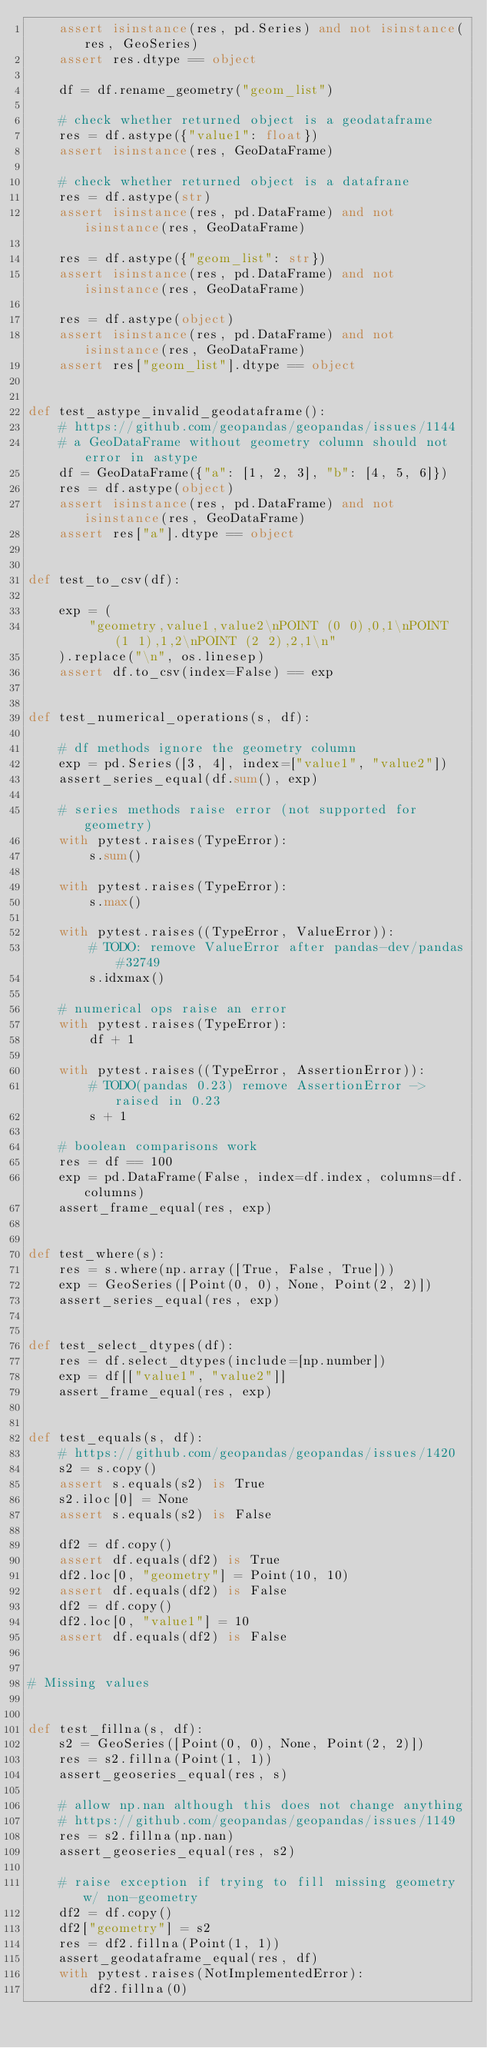<code> <loc_0><loc_0><loc_500><loc_500><_Python_>    assert isinstance(res, pd.Series) and not isinstance(res, GeoSeries)
    assert res.dtype == object

    df = df.rename_geometry("geom_list")

    # check whether returned object is a geodataframe
    res = df.astype({"value1": float})
    assert isinstance(res, GeoDataFrame)

    # check whether returned object is a datafrane
    res = df.astype(str)
    assert isinstance(res, pd.DataFrame) and not isinstance(res, GeoDataFrame)

    res = df.astype({"geom_list": str})
    assert isinstance(res, pd.DataFrame) and not isinstance(res, GeoDataFrame)

    res = df.astype(object)
    assert isinstance(res, pd.DataFrame) and not isinstance(res, GeoDataFrame)
    assert res["geom_list"].dtype == object


def test_astype_invalid_geodataframe():
    # https://github.com/geopandas/geopandas/issues/1144
    # a GeoDataFrame without geometry column should not error in astype
    df = GeoDataFrame({"a": [1, 2, 3], "b": [4, 5, 6]})
    res = df.astype(object)
    assert isinstance(res, pd.DataFrame) and not isinstance(res, GeoDataFrame)
    assert res["a"].dtype == object


def test_to_csv(df):

    exp = (
        "geometry,value1,value2\nPOINT (0 0),0,1\nPOINT (1 1),1,2\nPOINT (2 2),2,1\n"
    ).replace("\n", os.linesep)
    assert df.to_csv(index=False) == exp


def test_numerical_operations(s, df):

    # df methods ignore the geometry column
    exp = pd.Series([3, 4], index=["value1", "value2"])
    assert_series_equal(df.sum(), exp)

    # series methods raise error (not supported for geometry)
    with pytest.raises(TypeError):
        s.sum()

    with pytest.raises(TypeError):
        s.max()

    with pytest.raises((TypeError, ValueError)):
        # TODO: remove ValueError after pandas-dev/pandas#32749
        s.idxmax()

    # numerical ops raise an error
    with pytest.raises(TypeError):
        df + 1

    with pytest.raises((TypeError, AssertionError)):
        # TODO(pandas 0.23) remove AssertionError -> raised in 0.23
        s + 1

    # boolean comparisons work
    res = df == 100
    exp = pd.DataFrame(False, index=df.index, columns=df.columns)
    assert_frame_equal(res, exp)


def test_where(s):
    res = s.where(np.array([True, False, True]))
    exp = GeoSeries([Point(0, 0), None, Point(2, 2)])
    assert_series_equal(res, exp)


def test_select_dtypes(df):
    res = df.select_dtypes(include=[np.number])
    exp = df[["value1", "value2"]]
    assert_frame_equal(res, exp)


def test_equals(s, df):
    # https://github.com/geopandas/geopandas/issues/1420
    s2 = s.copy()
    assert s.equals(s2) is True
    s2.iloc[0] = None
    assert s.equals(s2) is False

    df2 = df.copy()
    assert df.equals(df2) is True
    df2.loc[0, "geometry"] = Point(10, 10)
    assert df.equals(df2) is False
    df2 = df.copy()
    df2.loc[0, "value1"] = 10
    assert df.equals(df2) is False


# Missing values


def test_fillna(s, df):
    s2 = GeoSeries([Point(0, 0), None, Point(2, 2)])
    res = s2.fillna(Point(1, 1))
    assert_geoseries_equal(res, s)

    # allow np.nan although this does not change anything
    # https://github.com/geopandas/geopandas/issues/1149
    res = s2.fillna(np.nan)
    assert_geoseries_equal(res, s2)

    # raise exception if trying to fill missing geometry w/ non-geometry
    df2 = df.copy()
    df2["geometry"] = s2
    res = df2.fillna(Point(1, 1))
    assert_geodataframe_equal(res, df)
    with pytest.raises(NotImplementedError):
        df2.fillna(0)
</code> 